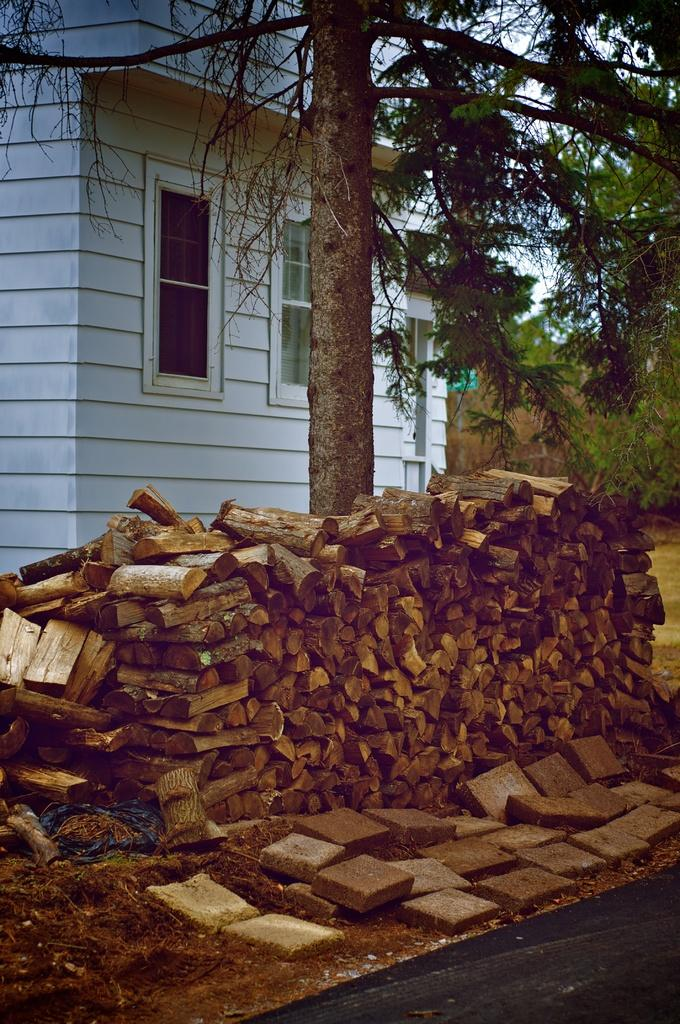What type of objects are stacked in the image? There is a group of wooden logs in the image, and they are placed one on top of the other. What other objects can be seen in the image? There are stones, a tree, a building with windows, and the sky is visible in the image. Where is the kettle placed in the image? There is no kettle present in the image. What is the chance of rain in the image? The image does not provide any information about the weather or the chance of rain. 